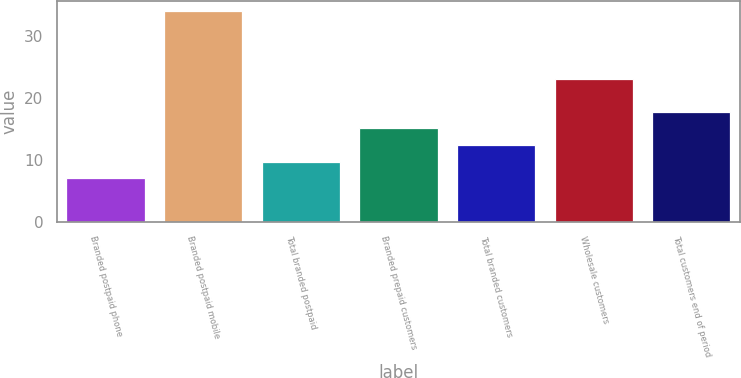Convert chart to OTSL. <chart><loc_0><loc_0><loc_500><loc_500><bar_chart><fcel>Branded postpaid phone<fcel>Branded postpaid mobile<fcel>Total branded postpaid<fcel>Branded prepaid customers<fcel>Total branded customers<fcel>Wholesale customers<fcel>Total customers end of period<nl><fcel>7<fcel>34<fcel>9.7<fcel>15.1<fcel>12.4<fcel>23<fcel>17.8<nl></chart> 